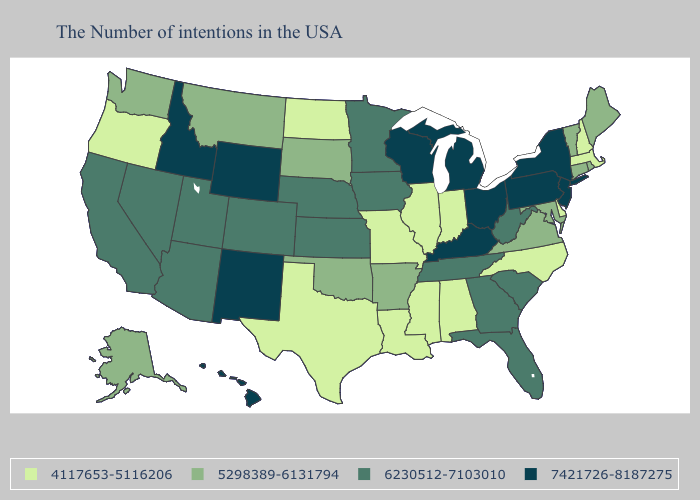Among the states that border Kansas , does Missouri have the highest value?
Short answer required. No. Does Wyoming have the lowest value in the USA?
Be succinct. No. What is the value of West Virginia?
Quick response, please. 6230512-7103010. Name the states that have a value in the range 7421726-8187275?
Quick response, please. New York, New Jersey, Pennsylvania, Ohio, Michigan, Kentucky, Wisconsin, Wyoming, New Mexico, Idaho, Hawaii. Name the states that have a value in the range 6230512-7103010?
Concise answer only. South Carolina, West Virginia, Florida, Georgia, Tennessee, Minnesota, Iowa, Kansas, Nebraska, Colorado, Utah, Arizona, Nevada, California. Name the states that have a value in the range 5298389-6131794?
Be succinct. Maine, Rhode Island, Vermont, Connecticut, Maryland, Virginia, Arkansas, Oklahoma, South Dakota, Montana, Washington, Alaska. Does New Jersey have the highest value in the USA?
Give a very brief answer. Yes. What is the lowest value in states that border Rhode Island?
Concise answer only. 4117653-5116206. What is the highest value in the USA?
Quick response, please. 7421726-8187275. Does Oregon have the lowest value in the USA?
Quick response, please. Yes. Which states have the lowest value in the South?
Write a very short answer. Delaware, North Carolina, Alabama, Mississippi, Louisiana, Texas. Does Louisiana have the lowest value in the South?
Short answer required. Yes. What is the value of Illinois?
Answer briefly. 4117653-5116206. What is the value of Colorado?
Be succinct. 6230512-7103010. What is the lowest value in the USA?
Write a very short answer. 4117653-5116206. 